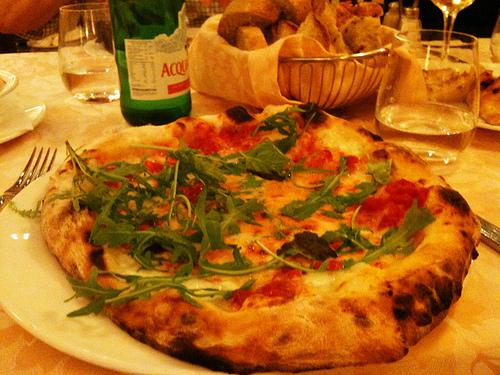Question: where is the bread basket?
Choices:
A. Upper center.
B. On the counter.
C. Below the toaster.
D. In the middle.
Answer with the letter. Answer: A Question: what is the pizza on?
Choices:
A. The cooking slab.
B. Box.
C. Plate.
D. Lips.
Answer with the letter. Answer: C Question: how many glasses?
Choices:
A. Four.
B. Five.
C. Three.
D. Two.
Answer with the letter. Answer: C 